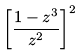<formula> <loc_0><loc_0><loc_500><loc_500>\left [ \frac { 1 - z ^ { 3 } } { z ^ { 2 } } \right ] ^ { 2 }</formula> 